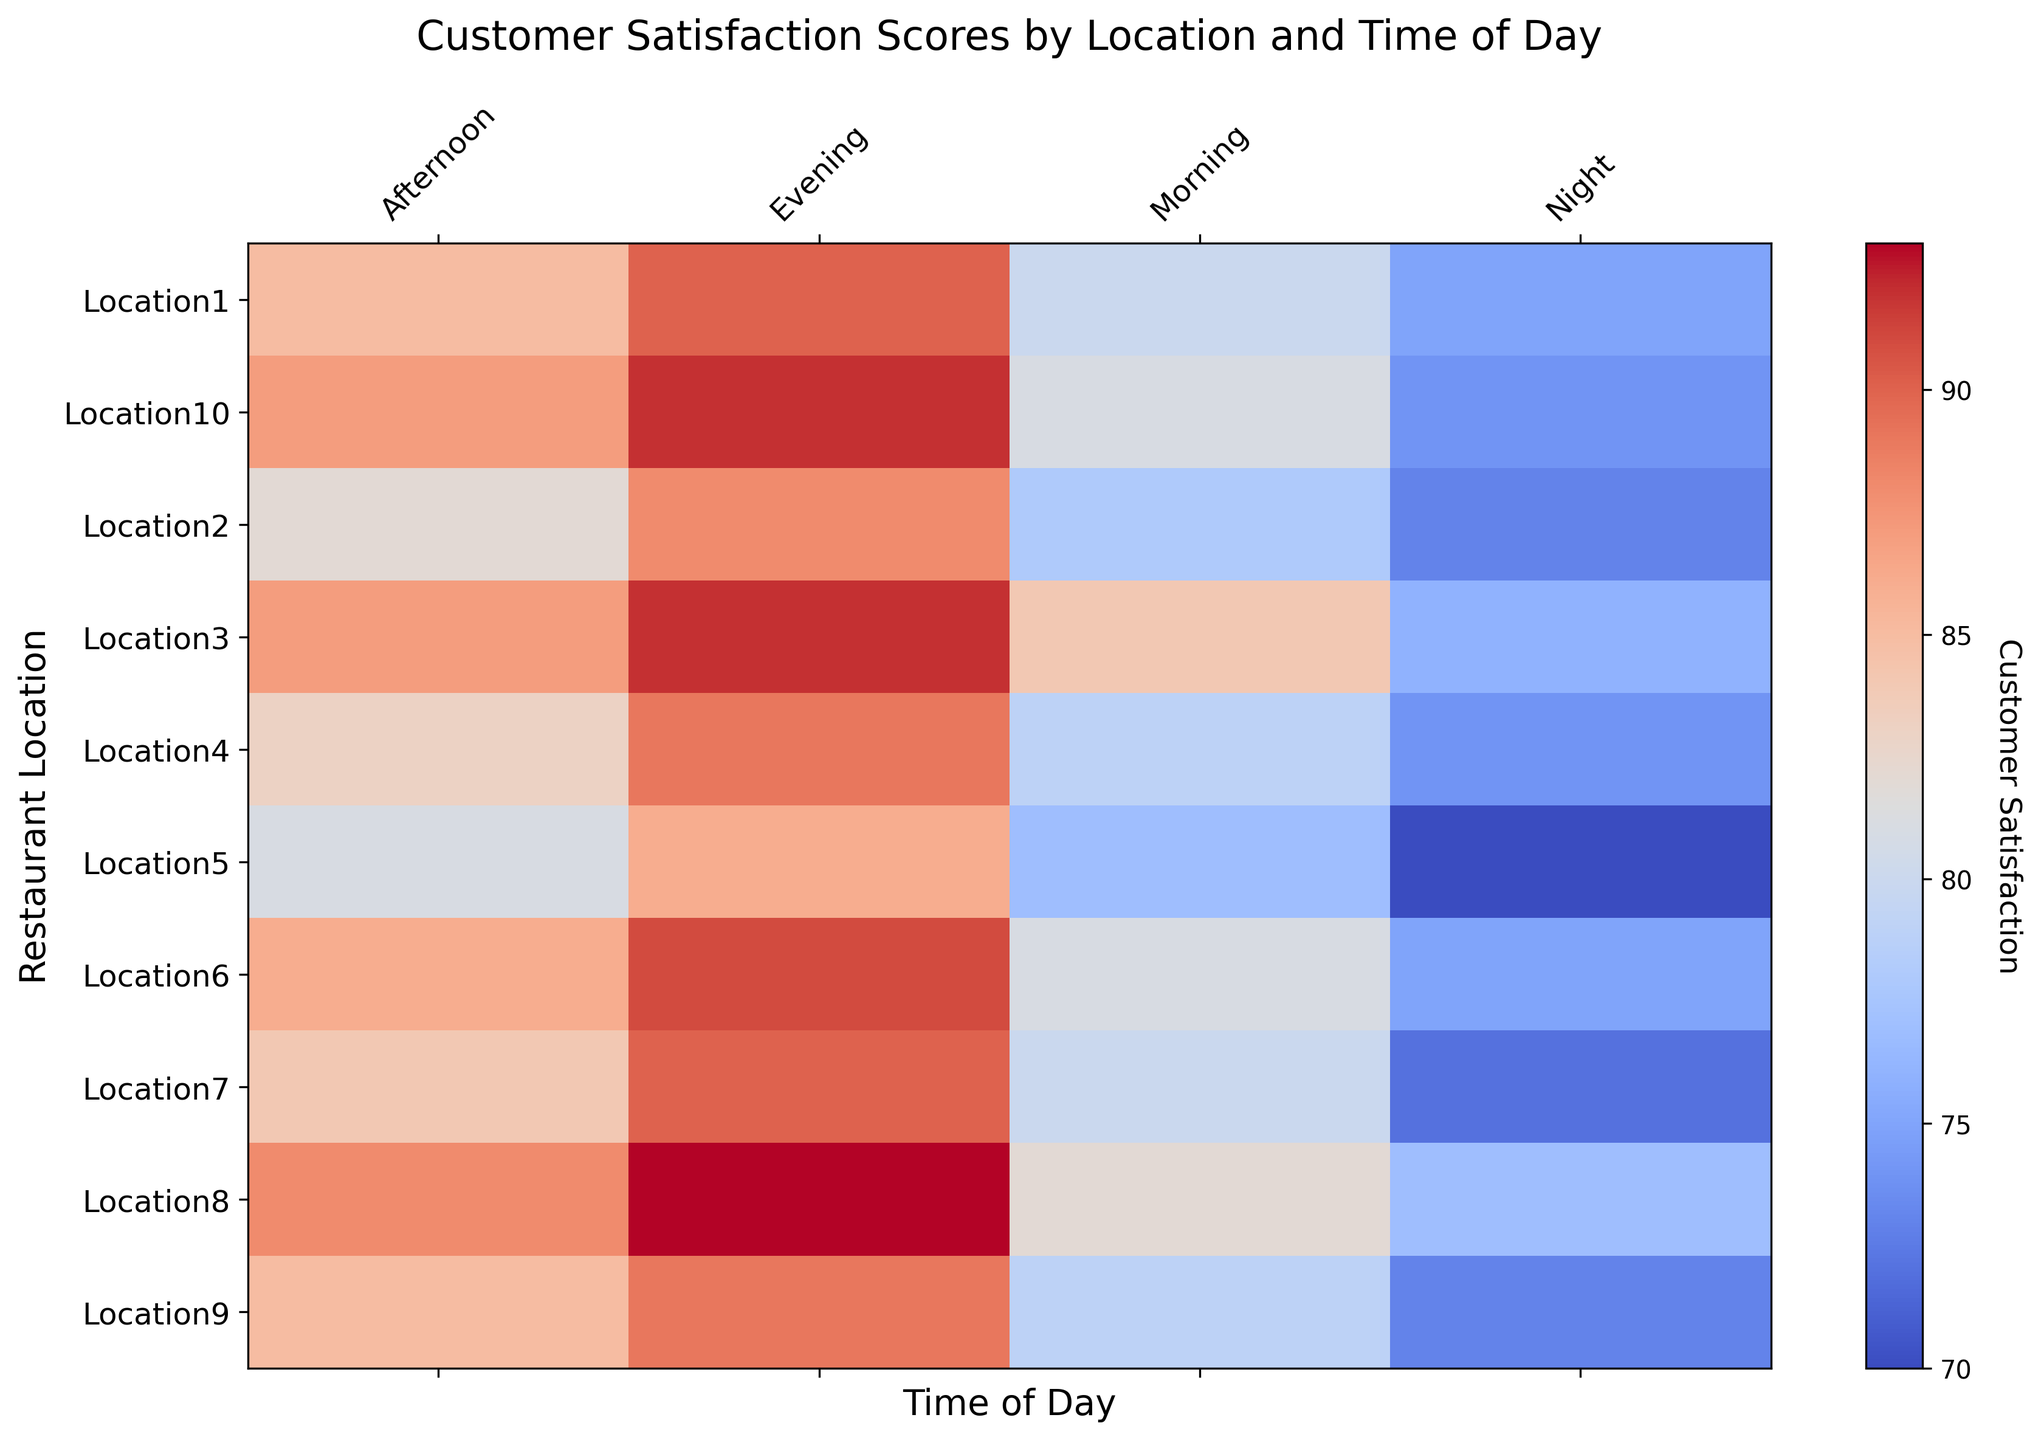Which restaurant location has the highest customer satisfaction score in the evening? To find the location with the highest satisfaction score in the evening, look for the darkest red cell in the "Evening" column. The highest satisfaction score in the evening is at Location8 with a score of 93.
Answer: Location8 What is the difference in customer satisfaction scores between Location1 in the morning and the evening? Check the scores for Location1 at Morning and Evening times. The score for Morning is 80 and Evening is 90. Subtract 80 from 90 to get the difference.
Answer: 10 Which time of day generally has the lowest customer satisfaction across all locations? Look for the time period that consistently shows lighter colors across the majority of locations. The "Night" time generally has the lowest satisfaction scores.
Answer: Night Compare the customer satisfaction of Location5 during the night with Location5 in the afternoon. Which one is higher? Look up the scores for Location5 at Night and Afternoon. The scores are 70 (Night) and 81 (Afternoon). The score is higher in the Afternoon.
Answer: Afternoon What is the average customer satisfaction score for Location6 across all times of the day? Retrieve all scores for Location6 (Morning: 81, Afternoon: 86, Evening: 91, Night: 75). Sum these scores (81+86+91+75) = 333, then divide by the number of time periods (4). The average score is 333/4.
Answer: 83.25 By how much does the satisfaction score at Location9 in the night lag behind Location9 in the evening? Observe the scores for Location9 at Night and Evening. The scores are 73 (Night) and 89 (Evening). Subtract 73 from 89 to find the difference.
Answer: 16 Which location has the most consistent customer satisfaction scores throughout the day? Identify the location with the least variance in colors across all times of the day. Location3 shows scores with minimal variation (84, 87, 92, 76), indicating consistency.
Answer: Location3 Compare the morning satisfaction scores of Location2 and Location4. Which is higher? Look at the satisfaction scores for Location2 and Location4 in the Morning. The scores are 78 (Location2) and 79 (Location4). Therefore, Location4 is higher.
Answer: Location4 What is the sum of customer satisfaction scores in the evening across all locations? Add the evening scores for all locations: 90 (Location1) + 88 (Location2) + 92 (Location3) + 89 (Location4) + 86 (Location5) + 91 (Location6) + 90 (Location7) + 93 (Location8) + 89 (Location9) + 92 (Location10) = 900.
Answer: 900 Which locations have customer satisfaction scores over 85 during the afternoon? Check the Afternoon column for scores higher than 85. Locations that meet this criteria are: Location3 (87), Location6 (86), Location8 (88), and Location10 (87).
Answer: Location3, Location6, Location8, Location10 